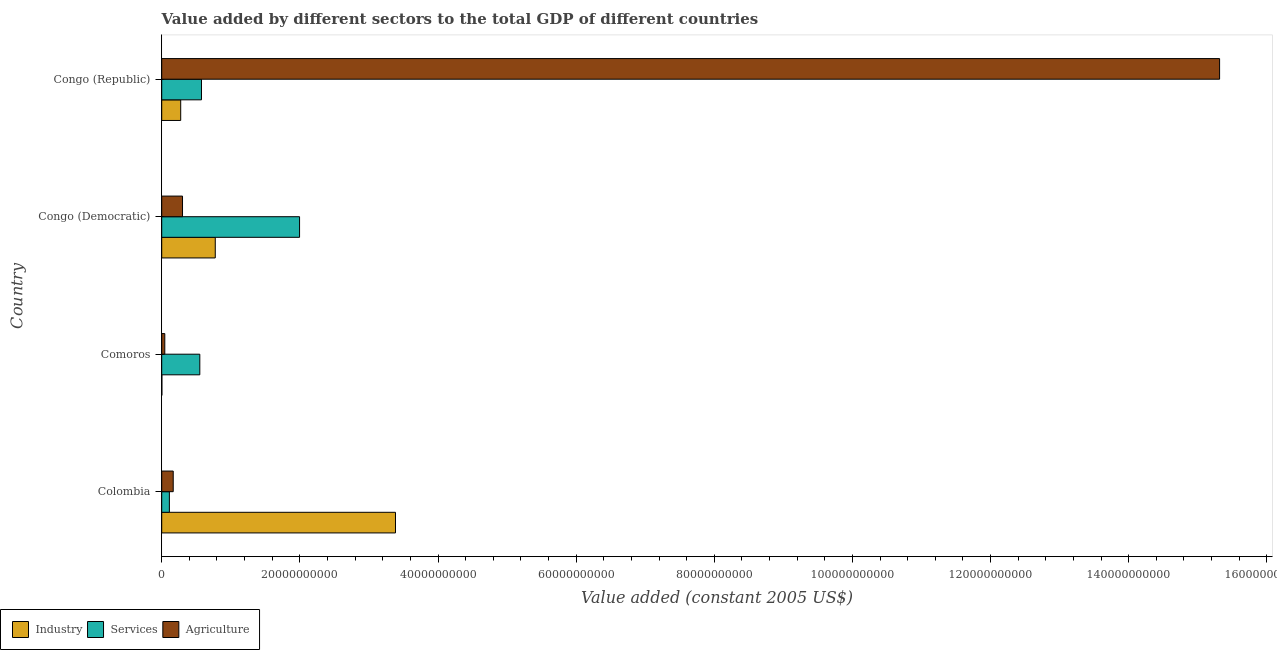How many different coloured bars are there?
Your answer should be compact. 3. Are the number of bars on each tick of the Y-axis equal?
Give a very brief answer. Yes. How many bars are there on the 2nd tick from the top?
Provide a short and direct response. 3. What is the label of the 2nd group of bars from the top?
Make the answer very short. Congo (Democratic). What is the value added by services in Congo (Democratic)?
Keep it short and to the point. 2.00e+1. Across all countries, what is the maximum value added by services?
Ensure brevity in your answer.  2.00e+1. Across all countries, what is the minimum value added by agricultural sector?
Your answer should be compact. 4.46e+08. In which country was the value added by services maximum?
Make the answer very short. Congo (Democratic). In which country was the value added by industrial sector minimum?
Make the answer very short. Comoros. What is the total value added by industrial sector in the graph?
Keep it short and to the point. 4.44e+1. What is the difference between the value added by industrial sector in Comoros and that in Congo (Republic)?
Your answer should be very brief. -2.73e+09. What is the difference between the value added by agricultural sector in Colombia and the value added by services in Congo (Republic)?
Offer a terse response. -4.09e+09. What is the average value added by industrial sector per country?
Give a very brief answer. 1.11e+1. What is the difference between the value added by services and value added by industrial sector in Congo (Republic)?
Give a very brief answer. 3.01e+09. In how many countries, is the value added by services greater than 24000000000 US$?
Offer a very short reply. 0. What is the ratio of the value added by services in Colombia to that in Comoros?
Your response must be concise. 0.2. Is the value added by agricultural sector in Congo (Democratic) less than that in Congo (Republic)?
Keep it short and to the point. Yes. Is the difference between the value added by industrial sector in Congo (Democratic) and Congo (Republic) greater than the difference between the value added by agricultural sector in Congo (Democratic) and Congo (Republic)?
Make the answer very short. Yes. What is the difference between the highest and the second highest value added by services?
Provide a short and direct response. 1.42e+1. What is the difference between the highest and the lowest value added by industrial sector?
Ensure brevity in your answer.  3.38e+1. What does the 3rd bar from the top in Comoros represents?
Your answer should be compact. Industry. What does the 2nd bar from the bottom in Comoros represents?
Your response must be concise. Services. Is it the case that in every country, the sum of the value added by industrial sector and value added by services is greater than the value added by agricultural sector?
Your answer should be compact. No. Are the values on the major ticks of X-axis written in scientific E-notation?
Provide a short and direct response. No. Does the graph contain grids?
Provide a succinct answer. No. How many legend labels are there?
Offer a terse response. 3. What is the title of the graph?
Provide a succinct answer. Value added by different sectors to the total GDP of different countries. What is the label or title of the X-axis?
Provide a short and direct response. Value added (constant 2005 US$). What is the label or title of the Y-axis?
Provide a short and direct response. Country. What is the Value added (constant 2005 US$) in Industry in Colombia?
Offer a very short reply. 3.38e+1. What is the Value added (constant 2005 US$) in Services in Colombia?
Offer a terse response. 1.11e+09. What is the Value added (constant 2005 US$) in Agriculture in Colombia?
Provide a succinct answer. 1.67e+09. What is the Value added (constant 2005 US$) of Industry in Comoros?
Your answer should be very brief. 2.37e+07. What is the Value added (constant 2005 US$) of Services in Comoros?
Offer a very short reply. 5.52e+09. What is the Value added (constant 2005 US$) in Agriculture in Comoros?
Offer a terse response. 4.46e+08. What is the Value added (constant 2005 US$) of Industry in Congo (Democratic)?
Ensure brevity in your answer.  7.75e+09. What is the Value added (constant 2005 US$) in Services in Congo (Democratic)?
Your response must be concise. 2.00e+1. What is the Value added (constant 2005 US$) in Agriculture in Congo (Democratic)?
Provide a succinct answer. 3.01e+09. What is the Value added (constant 2005 US$) in Industry in Congo (Republic)?
Ensure brevity in your answer.  2.75e+09. What is the Value added (constant 2005 US$) in Services in Congo (Republic)?
Your answer should be very brief. 5.76e+09. What is the Value added (constant 2005 US$) of Agriculture in Congo (Republic)?
Give a very brief answer. 1.53e+11. Across all countries, what is the maximum Value added (constant 2005 US$) in Industry?
Offer a very short reply. 3.38e+1. Across all countries, what is the maximum Value added (constant 2005 US$) of Services?
Keep it short and to the point. 2.00e+1. Across all countries, what is the maximum Value added (constant 2005 US$) of Agriculture?
Make the answer very short. 1.53e+11. Across all countries, what is the minimum Value added (constant 2005 US$) of Industry?
Your answer should be compact. 2.37e+07. Across all countries, what is the minimum Value added (constant 2005 US$) in Services?
Provide a short and direct response. 1.11e+09. Across all countries, what is the minimum Value added (constant 2005 US$) of Agriculture?
Make the answer very short. 4.46e+08. What is the total Value added (constant 2005 US$) of Industry in the graph?
Provide a succinct answer. 4.44e+1. What is the total Value added (constant 2005 US$) of Services in the graph?
Keep it short and to the point. 3.23e+1. What is the total Value added (constant 2005 US$) in Agriculture in the graph?
Keep it short and to the point. 1.58e+11. What is the difference between the Value added (constant 2005 US$) of Industry in Colombia and that in Comoros?
Offer a very short reply. 3.38e+1. What is the difference between the Value added (constant 2005 US$) of Services in Colombia and that in Comoros?
Offer a very short reply. -4.41e+09. What is the difference between the Value added (constant 2005 US$) in Agriculture in Colombia and that in Comoros?
Provide a short and direct response. 1.22e+09. What is the difference between the Value added (constant 2005 US$) of Industry in Colombia and that in Congo (Democratic)?
Give a very brief answer. 2.61e+1. What is the difference between the Value added (constant 2005 US$) in Services in Colombia and that in Congo (Democratic)?
Your answer should be very brief. -1.88e+1. What is the difference between the Value added (constant 2005 US$) in Agriculture in Colombia and that in Congo (Democratic)?
Make the answer very short. -1.35e+09. What is the difference between the Value added (constant 2005 US$) in Industry in Colombia and that in Congo (Republic)?
Offer a terse response. 3.11e+1. What is the difference between the Value added (constant 2005 US$) of Services in Colombia and that in Congo (Republic)?
Make the answer very short. -4.65e+09. What is the difference between the Value added (constant 2005 US$) in Agriculture in Colombia and that in Congo (Republic)?
Make the answer very short. -1.51e+11. What is the difference between the Value added (constant 2005 US$) in Industry in Comoros and that in Congo (Democratic)?
Make the answer very short. -7.73e+09. What is the difference between the Value added (constant 2005 US$) in Services in Comoros and that in Congo (Democratic)?
Keep it short and to the point. -1.44e+1. What is the difference between the Value added (constant 2005 US$) in Agriculture in Comoros and that in Congo (Democratic)?
Provide a short and direct response. -2.56e+09. What is the difference between the Value added (constant 2005 US$) of Industry in Comoros and that in Congo (Republic)?
Ensure brevity in your answer.  -2.73e+09. What is the difference between the Value added (constant 2005 US$) of Services in Comoros and that in Congo (Republic)?
Keep it short and to the point. -2.41e+08. What is the difference between the Value added (constant 2005 US$) of Agriculture in Comoros and that in Congo (Republic)?
Ensure brevity in your answer.  -1.53e+11. What is the difference between the Value added (constant 2005 US$) in Industry in Congo (Democratic) and that in Congo (Republic)?
Offer a terse response. 5.00e+09. What is the difference between the Value added (constant 2005 US$) in Services in Congo (Democratic) and that in Congo (Republic)?
Offer a terse response. 1.42e+1. What is the difference between the Value added (constant 2005 US$) of Agriculture in Congo (Democratic) and that in Congo (Republic)?
Give a very brief answer. -1.50e+11. What is the difference between the Value added (constant 2005 US$) of Industry in Colombia and the Value added (constant 2005 US$) of Services in Comoros?
Make the answer very short. 2.83e+1. What is the difference between the Value added (constant 2005 US$) in Industry in Colombia and the Value added (constant 2005 US$) in Agriculture in Comoros?
Provide a short and direct response. 3.34e+1. What is the difference between the Value added (constant 2005 US$) of Services in Colombia and the Value added (constant 2005 US$) of Agriculture in Comoros?
Your answer should be compact. 6.65e+08. What is the difference between the Value added (constant 2005 US$) of Industry in Colombia and the Value added (constant 2005 US$) of Services in Congo (Democratic)?
Keep it short and to the point. 1.39e+1. What is the difference between the Value added (constant 2005 US$) in Industry in Colombia and the Value added (constant 2005 US$) in Agriculture in Congo (Democratic)?
Your answer should be compact. 3.08e+1. What is the difference between the Value added (constant 2005 US$) of Services in Colombia and the Value added (constant 2005 US$) of Agriculture in Congo (Democratic)?
Your answer should be compact. -1.90e+09. What is the difference between the Value added (constant 2005 US$) in Industry in Colombia and the Value added (constant 2005 US$) in Services in Congo (Republic)?
Provide a succinct answer. 2.81e+1. What is the difference between the Value added (constant 2005 US$) of Industry in Colombia and the Value added (constant 2005 US$) of Agriculture in Congo (Republic)?
Give a very brief answer. -1.19e+11. What is the difference between the Value added (constant 2005 US$) of Services in Colombia and the Value added (constant 2005 US$) of Agriculture in Congo (Republic)?
Provide a short and direct response. -1.52e+11. What is the difference between the Value added (constant 2005 US$) in Industry in Comoros and the Value added (constant 2005 US$) in Services in Congo (Democratic)?
Keep it short and to the point. -1.99e+1. What is the difference between the Value added (constant 2005 US$) of Industry in Comoros and the Value added (constant 2005 US$) of Agriculture in Congo (Democratic)?
Keep it short and to the point. -2.99e+09. What is the difference between the Value added (constant 2005 US$) in Services in Comoros and the Value added (constant 2005 US$) in Agriculture in Congo (Democratic)?
Ensure brevity in your answer.  2.51e+09. What is the difference between the Value added (constant 2005 US$) of Industry in Comoros and the Value added (constant 2005 US$) of Services in Congo (Republic)?
Give a very brief answer. -5.73e+09. What is the difference between the Value added (constant 2005 US$) of Industry in Comoros and the Value added (constant 2005 US$) of Agriculture in Congo (Republic)?
Offer a very short reply. -1.53e+11. What is the difference between the Value added (constant 2005 US$) of Services in Comoros and the Value added (constant 2005 US$) of Agriculture in Congo (Republic)?
Your response must be concise. -1.48e+11. What is the difference between the Value added (constant 2005 US$) of Industry in Congo (Democratic) and the Value added (constant 2005 US$) of Services in Congo (Republic)?
Provide a short and direct response. 2.00e+09. What is the difference between the Value added (constant 2005 US$) in Industry in Congo (Democratic) and the Value added (constant 2005 US$) in Agriculture in Congo (Republic)?
Your answer should be compact. -1.45e+11. What is the difference between the Value added (constant 2005 US$) of Services in Congo (Democratic) and the Value added (constant 2005 US$) of Agriculture in Congo (Republic)?
Your response must be concise. -1.33e+11. What is the average Value added (constant 2005 US$) of Industry per country?
Make the answer very short. 1.11e+1. What is the average Value added (constant 2005 US$) in Services per country?
Keep it short and to the point. 8.09e+09. What is the average Value added (constant 2005 US$) in Agriculture per country?
Offer a terse response. 3.96e+1. What is the difference between the Value added (constant 2005 US$) of Industry and Value added (constant 2005 US$) of Services in Colombia?
Your answer should be very brief. 3.27e+1. What is the difference between the Value added (constant 2005 US$) in Industry and Value added (constant 2005 US$) in Agriculture in Colombia?
Provide a short and direct response. 3.22e+1. What is the difference between the Value added (constant 2005 US$) in Services and Value added (constant 2005 US$) in Agriculture in Colombia?
Keep it short and to the point. -5.55e+08. What is the difference between the Value added (constant 2005 US$) in Industry and Value added (constant 2005 US$) in Services in Comoros?
Make the answer very short. -5.49e+09. What is the difference between the Value added (constant 2005 US$) of Industry and Value added (constant 2005 US$) of Agriculture in Comoros?
Make the answer very short. -4.22e+08. What is the difference between the Value added (constant 2005 US$) of Services and Value added (constant 2005 US$) of Agriculture in Comoros?
Your answer should be very brief. 5.07e+09. What is the difference between the Value added (constant 2005 US$) in Industry and Value added (constant 2005 US$) in Services in Congo (Democratic)?
Give a very brief answer. -1.22e+1. What is the difference between the Value added (constant 2005 US$) of Industry and Value added (constant 2005 US$) of Agriculture in Congo (Democratic)?
Provide a succinct answer. 4.74e+09. What is the difference between the Value added (constant 2005 US$) of Services and Value added (constant 2005 US$) of Agriculture in Congo (Democratic)?
Keep it short and to the point. 1.69e+1. What is the difference between the Value added (constant 2005 US$) of Industry and Value added (constant 2005 US$) of Services in Congo (Republic)?
Offer a very short reply. -3.01e+09. What is the difference between the Value added (constant 2005 US$) of Industry and Value added (constant 2005 US$) of Agriculture in Congo (Republic)?
Provide a short and direct response. -1.50e+11. What is the difference between the Value added (constant 2005 US$) in Services and Value added (constant 2005 US$) in Agriculture in Congo (Republic)?
Your answer should be compact. -1.47e+11. What is the ratio of the Value added (constant 2005 US$) of Industry in Colombia to that in Comoros?
Your answer should be compact. 1426.68. What is the ratio of the Value added (constant 2005 US$) of Services in Colombia to that in Comoros?
Ensure brevity in your answer.  0.2. What is the ratio of the Value added (constant 2005 US$) of Agriculture in Colombia to that in Comoros?
Give a very brief answer. 3.73. What is the ratio of the Value added (constant 2005 US$) of Industry in Colombia to that in Congo (Democratic)?
Your response must be concise. 4.36. What is the ratio of the Value added (constant 2005 US$) in Services in Colombia to that in Congo (Democratic)?
Ensure brevity in your answer.  0.06. What is the ratio of the Value added (constant 2005 US$) in Agriculture in Colombia to that in Congo (Democratic)?
Provide a short and direct response. 0.55. What is the ratio of the Value added (constant 2005 US$) in Industry in Colombia to that in Congo (Republic)?
Offer a very short reply. 12.31. What is the ratio of the Value added (constant 2005 US$) in Services in Colombia to that in Congo (Republic)?
Your response must be concise. 0.19. What is the ratio of the Value added (constant 2005 US$) in Agriculture in Colombia to that in Congo (Republic)?
Provide a succinct answer. 0.01. What is the ratio of the Value added (constant 2005 US$) of Industry in Comoros to that in Congo (Democratic)?
Ensure brevity in your answer.  0. What is the ratio of the Value added (constant 2005 US$) of Services in Comoros to that in Congo (Democratic)?
Offer a terse response. 0.28. What is the ratio of the Value added (constant 2005 US$) in Agriculture in Comoros to that in Congo (Democratic)?
Ensure brevity in your answer.  0.15. What is the ratio of the Value added (constant 2005 US$) in Industry in Comoros to that in Congo (Republic)?
Your response must be concise. 0.01. What is the ratio of the Value added (constant 2005 US$) of Services in Comoros to that in Congo (Republic)?
Your response must be concise. 0.96. What is the ratio of the Value added (constant 2005 US$) of Agriculture in Comoros to that in Congo (Republic)?
Provide a succinct answer. 0. What is the ratio of the Value added (constant 2005 US$) in Industry in Congo (Democratic) to that in Congo (Republic)?
Ensure brevity in your answer.  2.82. What is the ratio of the Value added (constant 2005 US$) in Services in Congo (Democratic) to that in Congo (Republic)?
Provide a short and direct response. 3.47. What is the ratio of the Value added (constant 2005 US$) of Agriculture in Congo (Democratic) to that in Congo (Republic)?
Provide a succinct answer. 0.02. What is the difference between the highest and the second highest Value added (constant 2005 US$) of Industry?
Make the answer very short. 2.61e+1. What is the difference between the highest and the second highest Value added (constant 2005 US$) of Services?
Offer a terse response. 1.42e+1. What is the difference between the highest and the second highest Value added (constant 2005 US$) of Agriculture?
Provide a short and direct response. 1.50e+11. What is the difference between the highest and the lowest Value added (constant 2005 US$) in Industry?
Your response must be concise. 3.38e+1. What is the difference between the highest and the lowest Value added (constant 2005 US$) in Services?
Offer a very short reply. 1.88e+1. What is the difference between the highest and the lowest Value added (constant 2005 US$) in Agriculture?
Offer a terse response. 1.53e+11. 